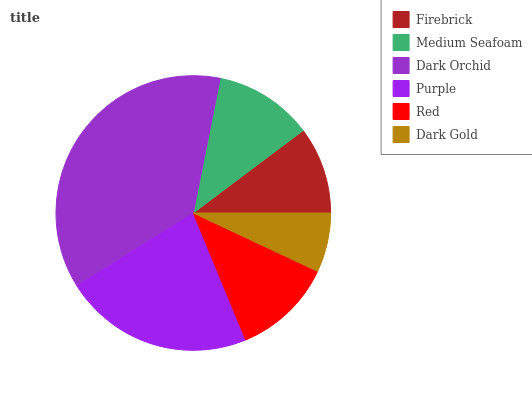Is Dark Gold the minimum?
Answer yes or no. Yes. Is Dark Orchid the maximum?
Answer yes or no. Yes. Is Medium Seafoam the minimum?
Answer yes or no. No. Is Medium Seafoam the maximum?
Answer yes or no. No. Is Medium Seafoam greater than Firebrick?
Answer yes or no. Yes. Is Firebrick less than Medium Seafoam?
Answer yes or no. Yes. Is Firebrick greater than Medium Seafoam?
Answer yes or no. No. Is Medium Seafoam less than Firebrick?
Answer yes or no. No. Is Red the high median?
Answer yes or no. Yes. Is Medium Seafoam the low median?
Answer yes or no. Yes. Is Firebrick the high median?
Answer yes or no. No. Is Dark Orchid the low median?
Answer yes or no. No. 